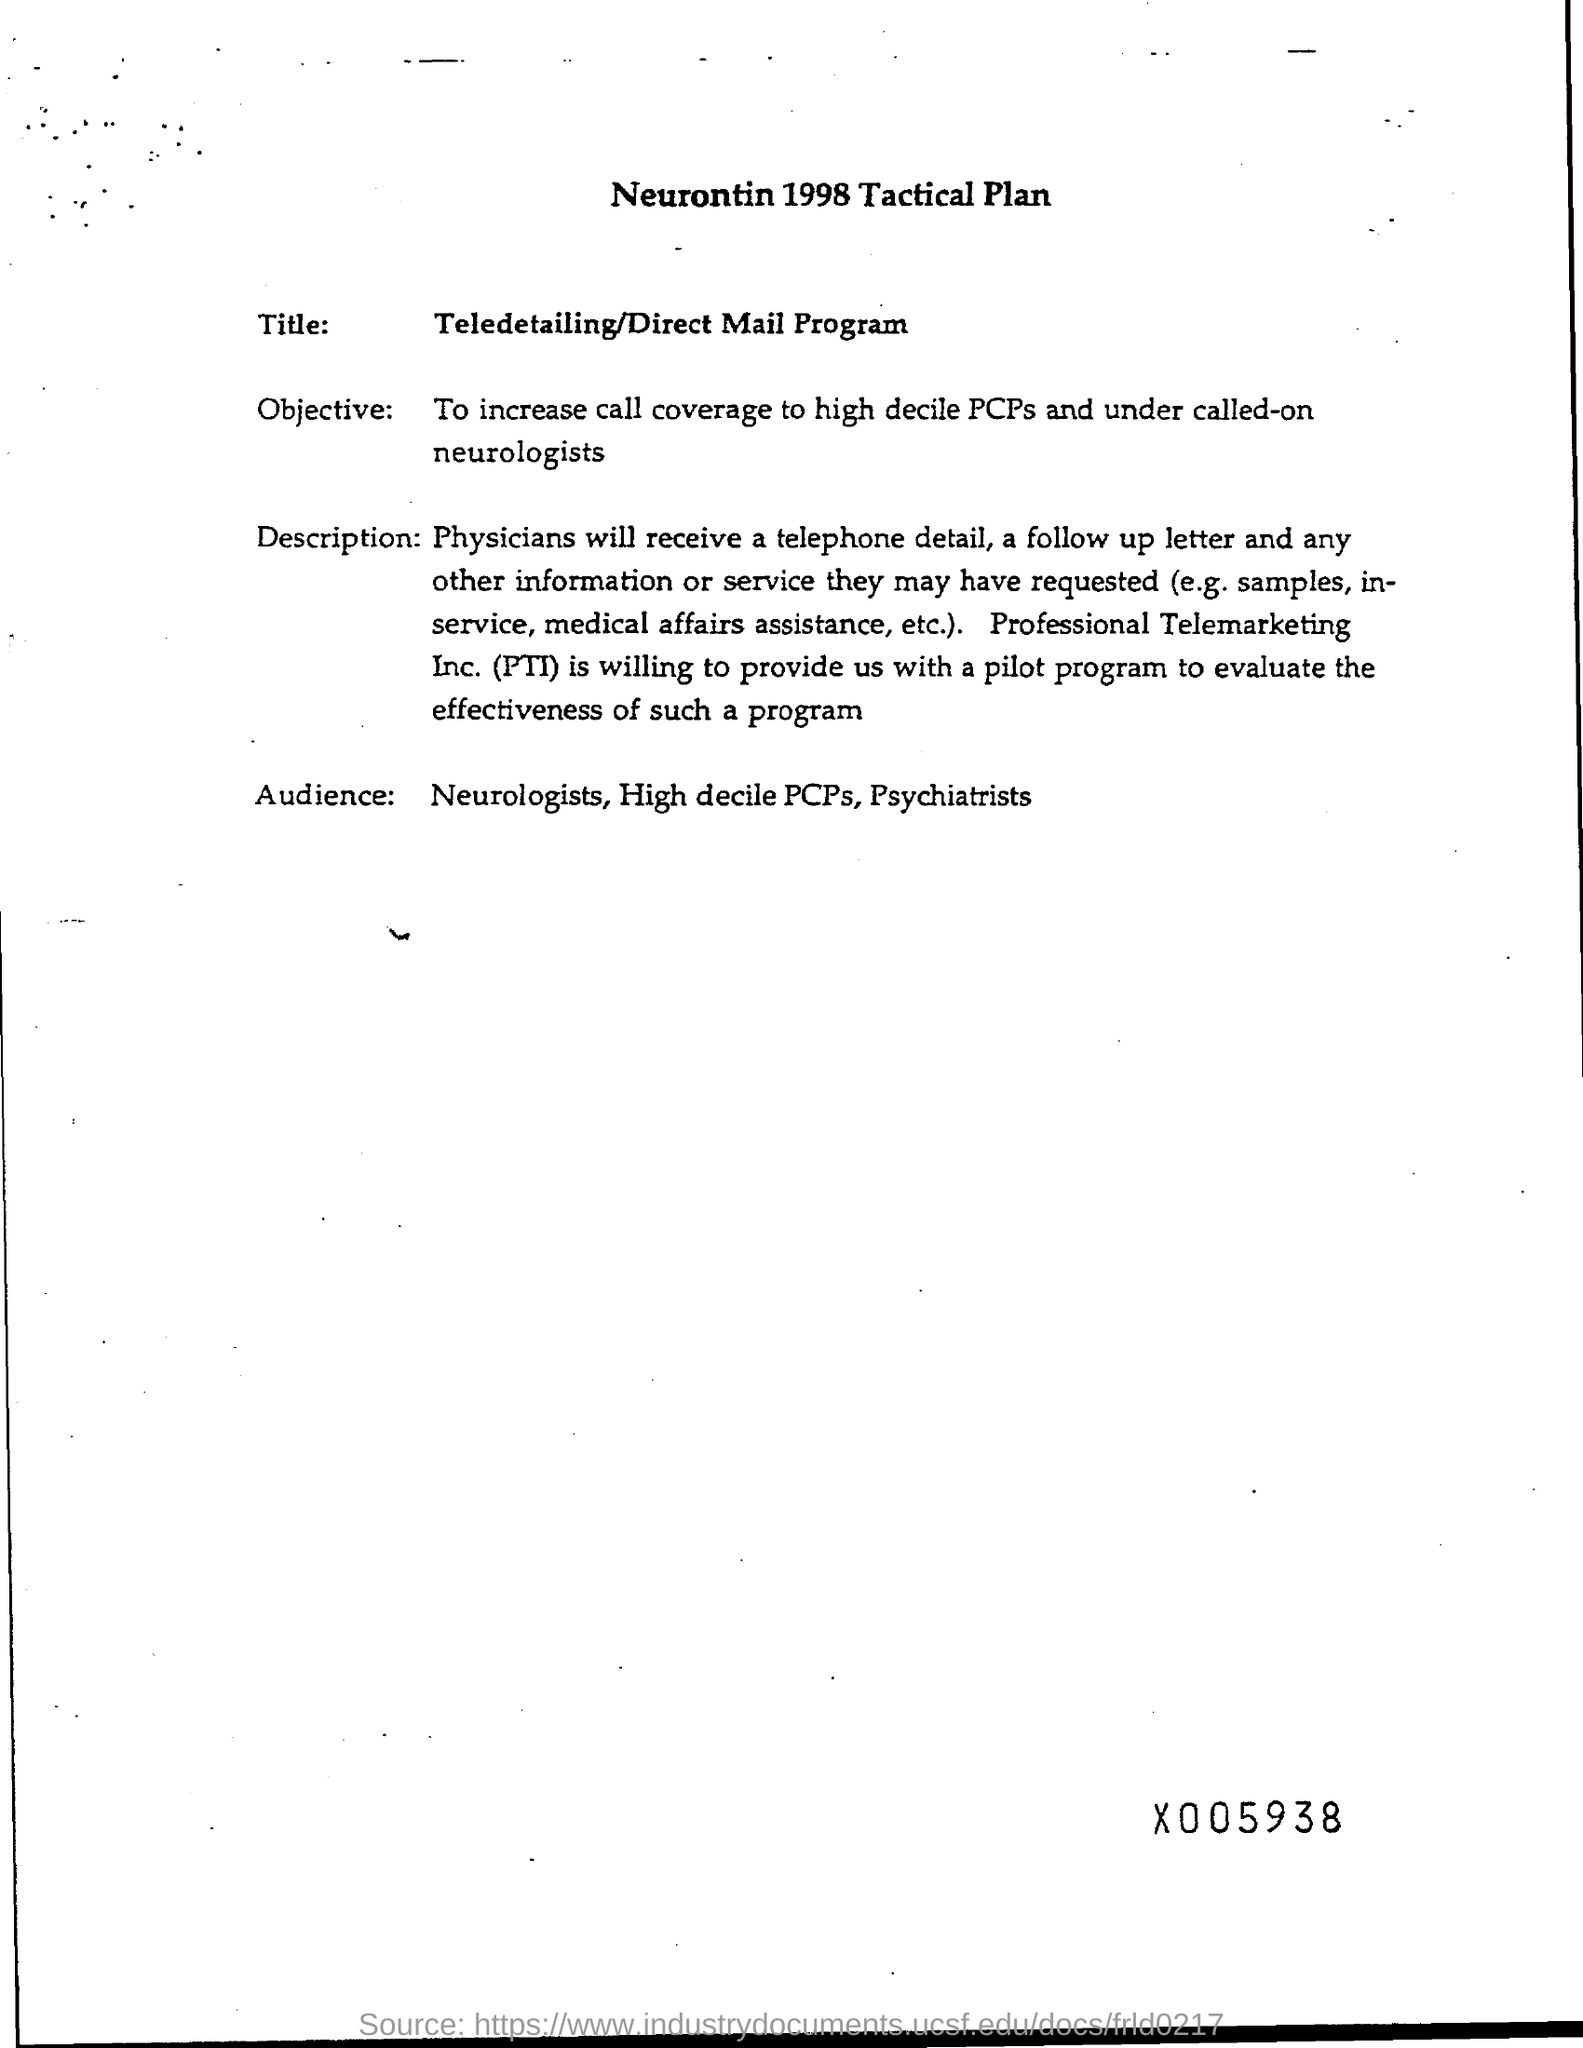What is the year mentioned in the heading of the document?
Keep it short and to the point. 1998. What is the Title?
Your answer should be compact. Teledetailing/Direct Mail Program. What is the Objective?
Provide a short and direct response. To increase call coverage to high decile PCPs and under called-on neurologists. Who are the Audience?
Give a very brief answer. Neurologists, High decile PCPs, Psychiatrists. What does PTI stand for?
Your response must be concise. Professional Telemarketing Inc. 